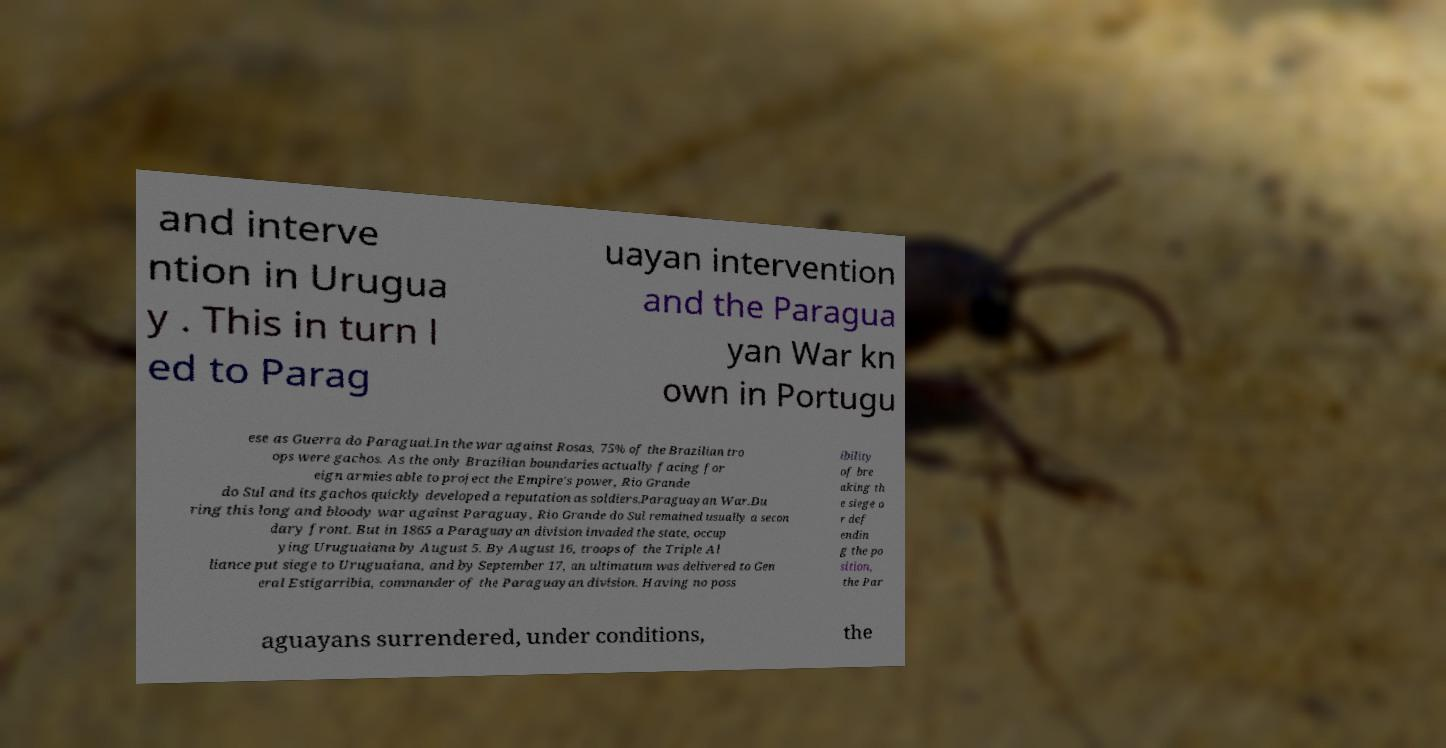There's text embedded in this image that I need extracted. Can you transcribe it verbatim? and interve ntion in Urugua y . This in turn l ed to Parag uayan intervention and the Paragua yan War kn own in Portugu ese as Guerra do Paraguai.In the war against Rosas, 75% of the Brazilian tro ops were gachos. As the only Brazilian boundaries actually facing for eign armies able to project the Empire's power, Rio Grande do Sul and its gachos quickly developed a reputation as soldiers.Paraguayan War.Du ring this long and bloody war against Paraguay, Rio Grande do Sul remained usually a secon dary front. But in 1865 a Paraguayan division invaded the state, occup ying Uruguaiana by August 5. By August 16, troops of the Triple Al liance put siege to Uruguaiana, and by September 17, an ultimatum was delivered to Gen eral Estigarribia, commander of the Paraguayan division. Having no poss ibility of bre aking th e siege o r def endin g the po sition, the Par aguayans surrendered, under conditions, the 